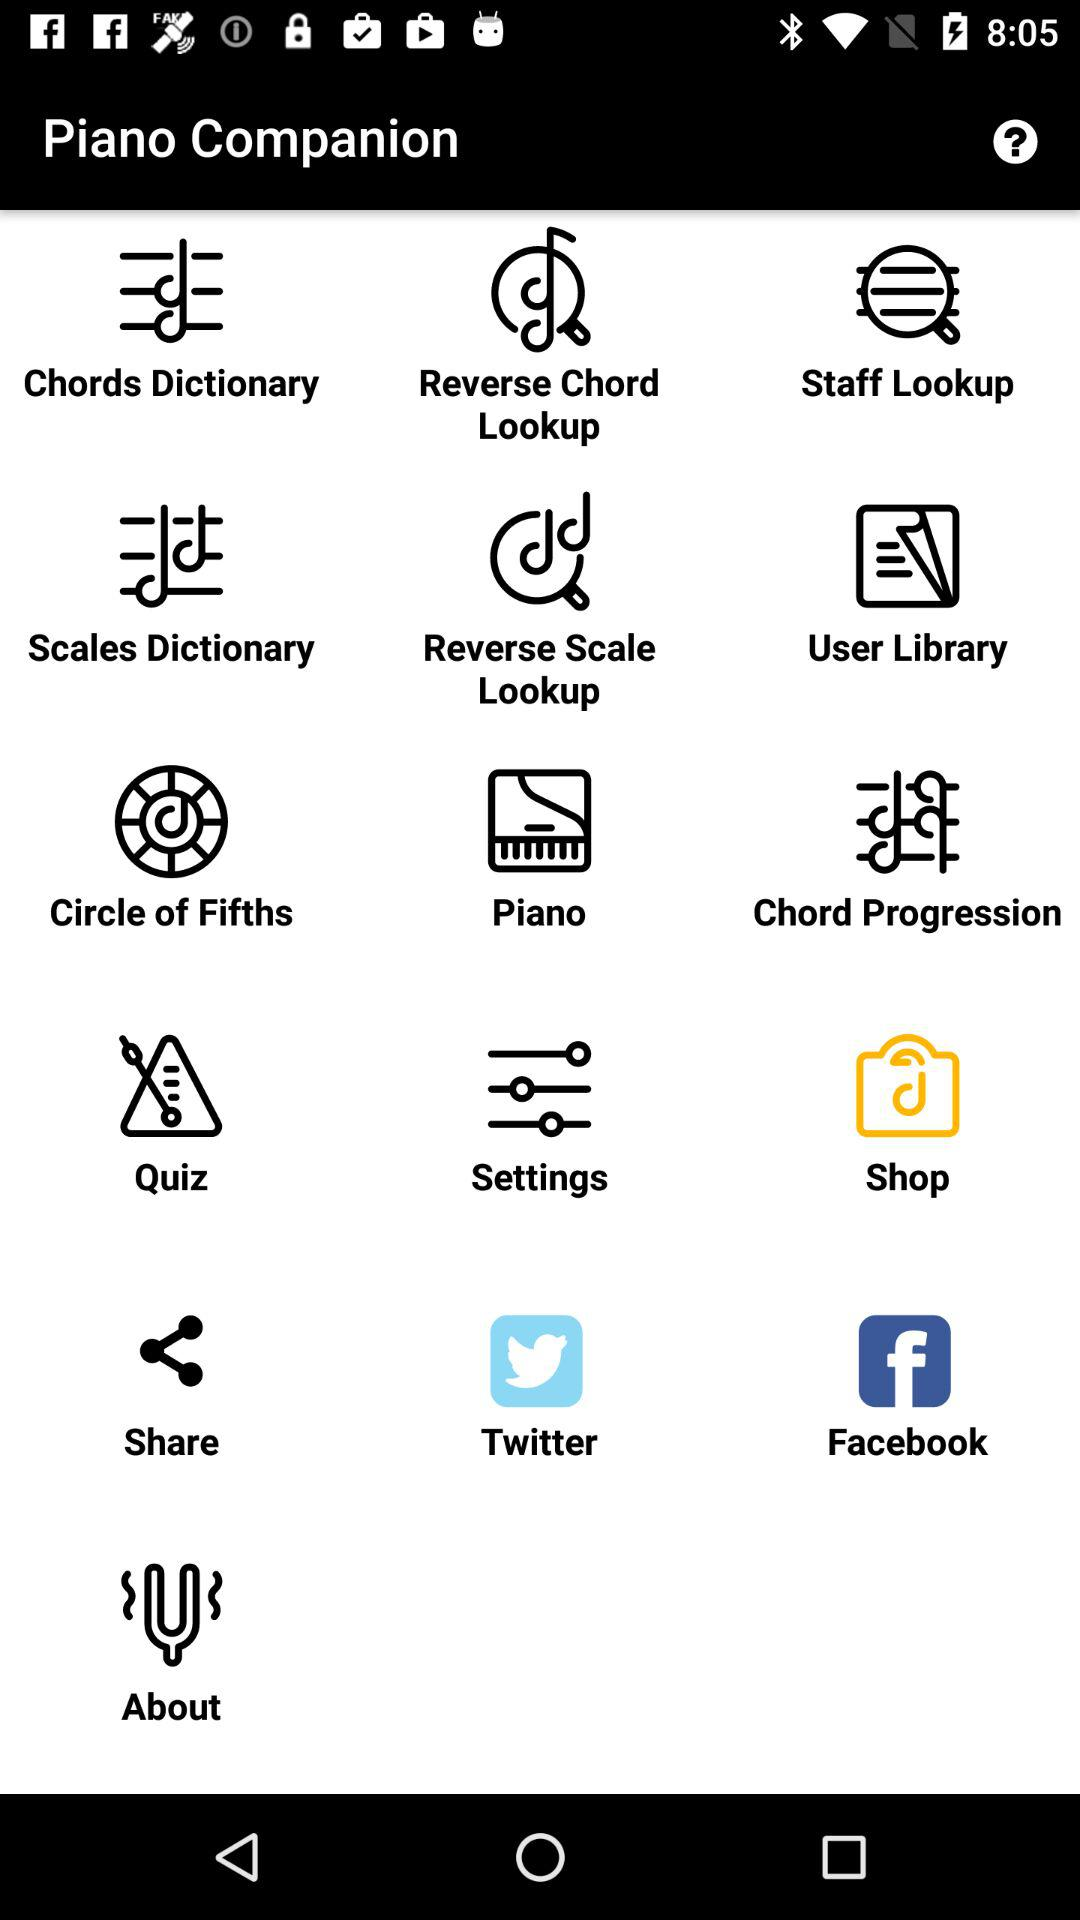What is the app name? The app name is "Piano Companion". 